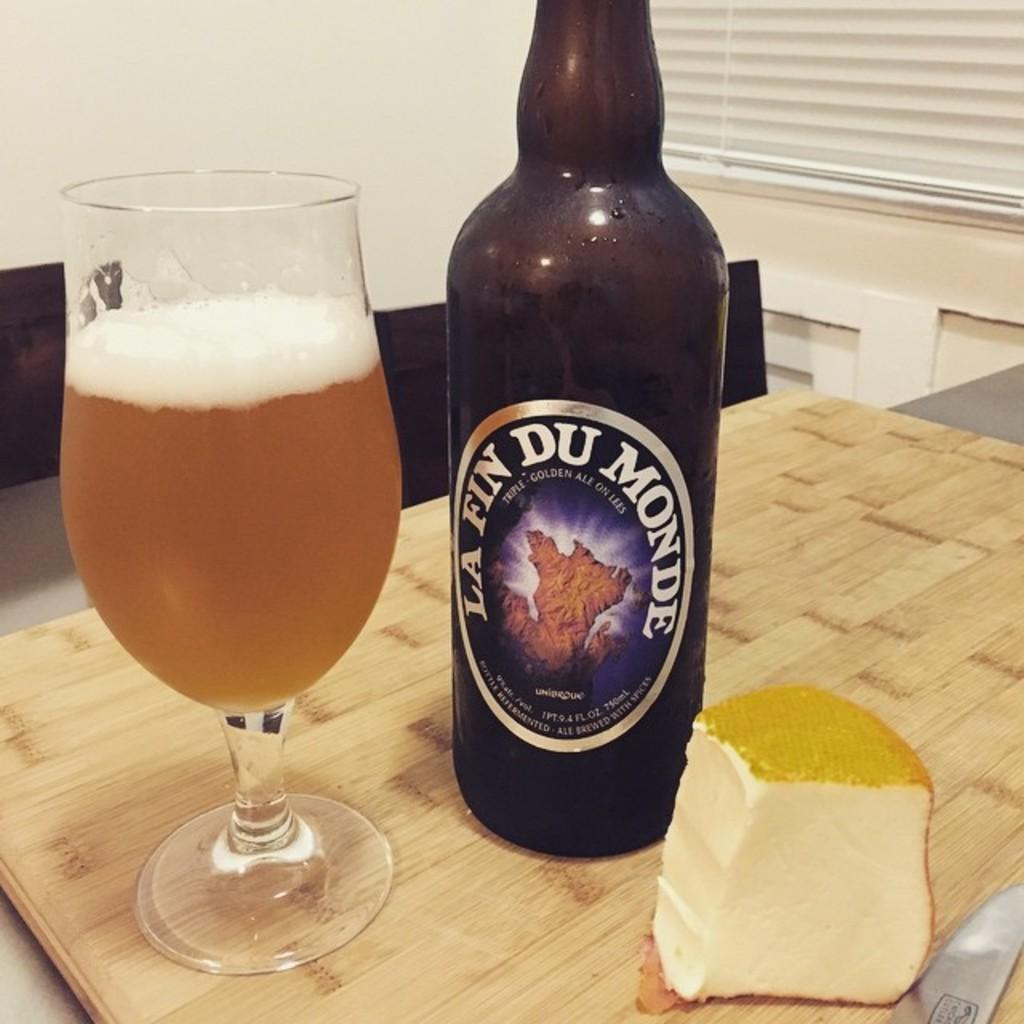<image>
Summarize the visual content of the image. A bottle of La Fin Du Monde sits next to a glass of beer and chunk of cheese. 